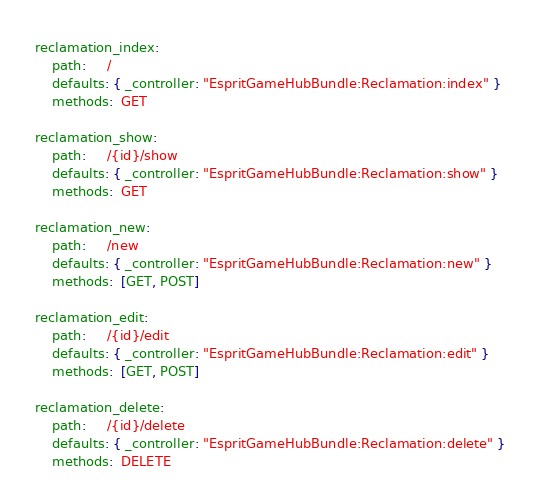Convert code to text. <code><loc_0><loc_0><loc_500><loc_500><_YAML_>reclamation_index:
    path:     /
    defaults: { _controller: "EspritGameHubBundle:Reclamation:index" }
    methods:  GET

reclamation_show:
    path:     /{id}/show
    defaults: { _controller: "EspritGameHubBundle:Reclamation:show" }
    methods:  GET

reclamation_new:
    path:     /new
    defaults: { _controller: "EspritGameHubBundle:Reclamation:new" }
    methods:  [GET, POST]

reclamation_edit:
    path:     /{id}/edit
    defaults: { _controller: "EspritGameHubBundle:Reclamation:edit" }
    methods:  [GET, POST]

reclamation_delete:
    path:     /{id}/delete
    defaults: { _controller: "EspritGameHubBundle:Reclamation:delete" }
    methods:  DELETE
</code> 